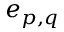<formula> <loc_0><loc_0><loc_500><loc_500>e _ { p , q }</formula> 